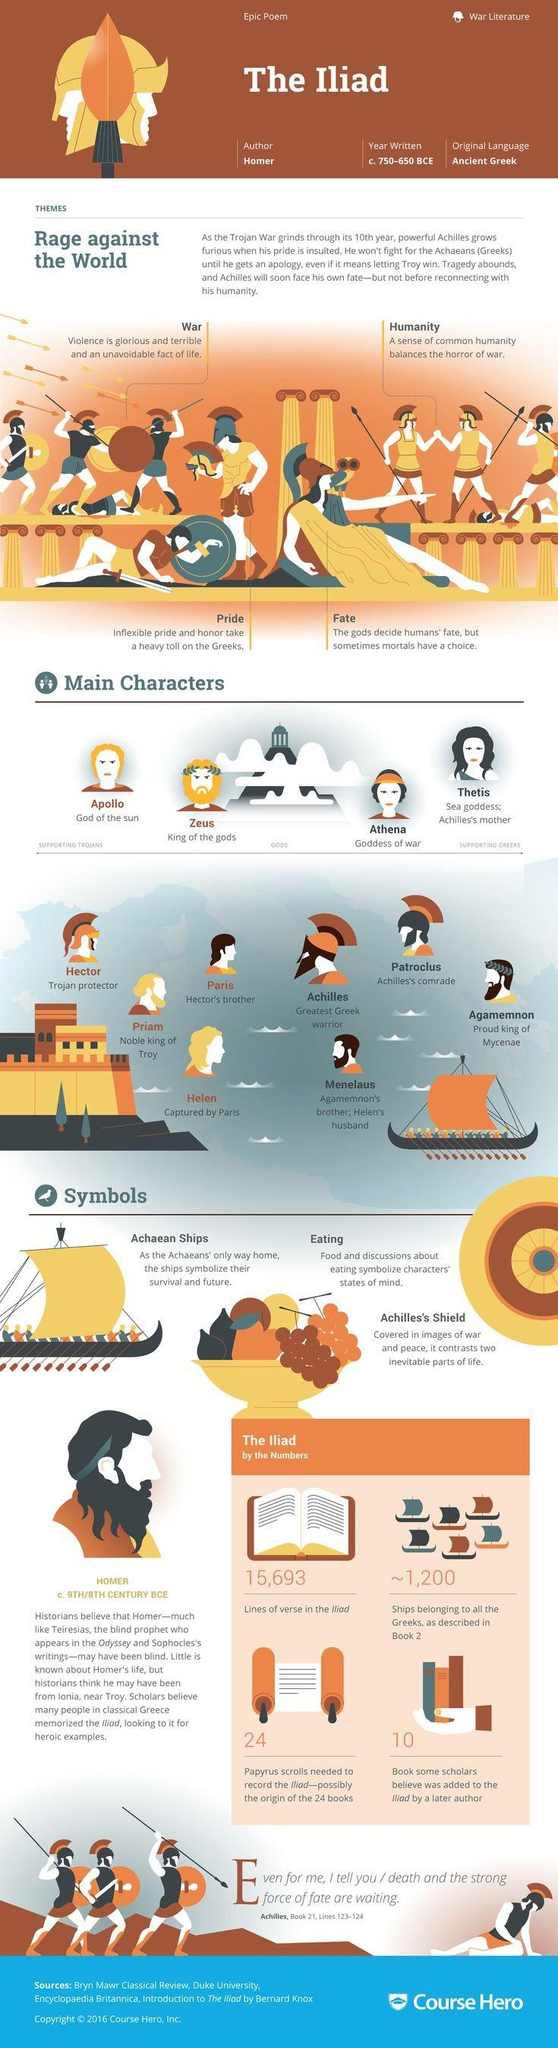Mention a couple of crucial points in this snapshot. It is Priam who is the king of Troy in the Iliad. The Iliad was written by Homer. Achilles is the greatest Trojan warrior in the Iliad, according to the declaration. There are 15,693 lines of verse in the Iliad. The original language of the Iliad is ancient Greek. 